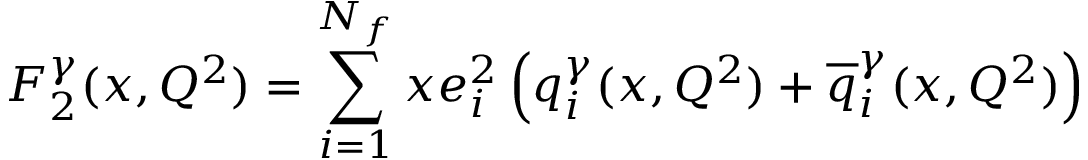<formula> <loc_0><loc_0><loc_500><loc_500>F _ { 2 } ^ { \gamma } ( x , Q ^ { 2 } ) = \sum _ { i = 1 } ^ { N _ { f } } x e _ { i } ^ { 2 } \left ( q _ { i } ^ { \gamma } ( x , Q ^ { 2 } ) + { \overline { q } } _ { i } ^ { \gamma } ( x , Q ^ { 2 } ) \right )</formula> 